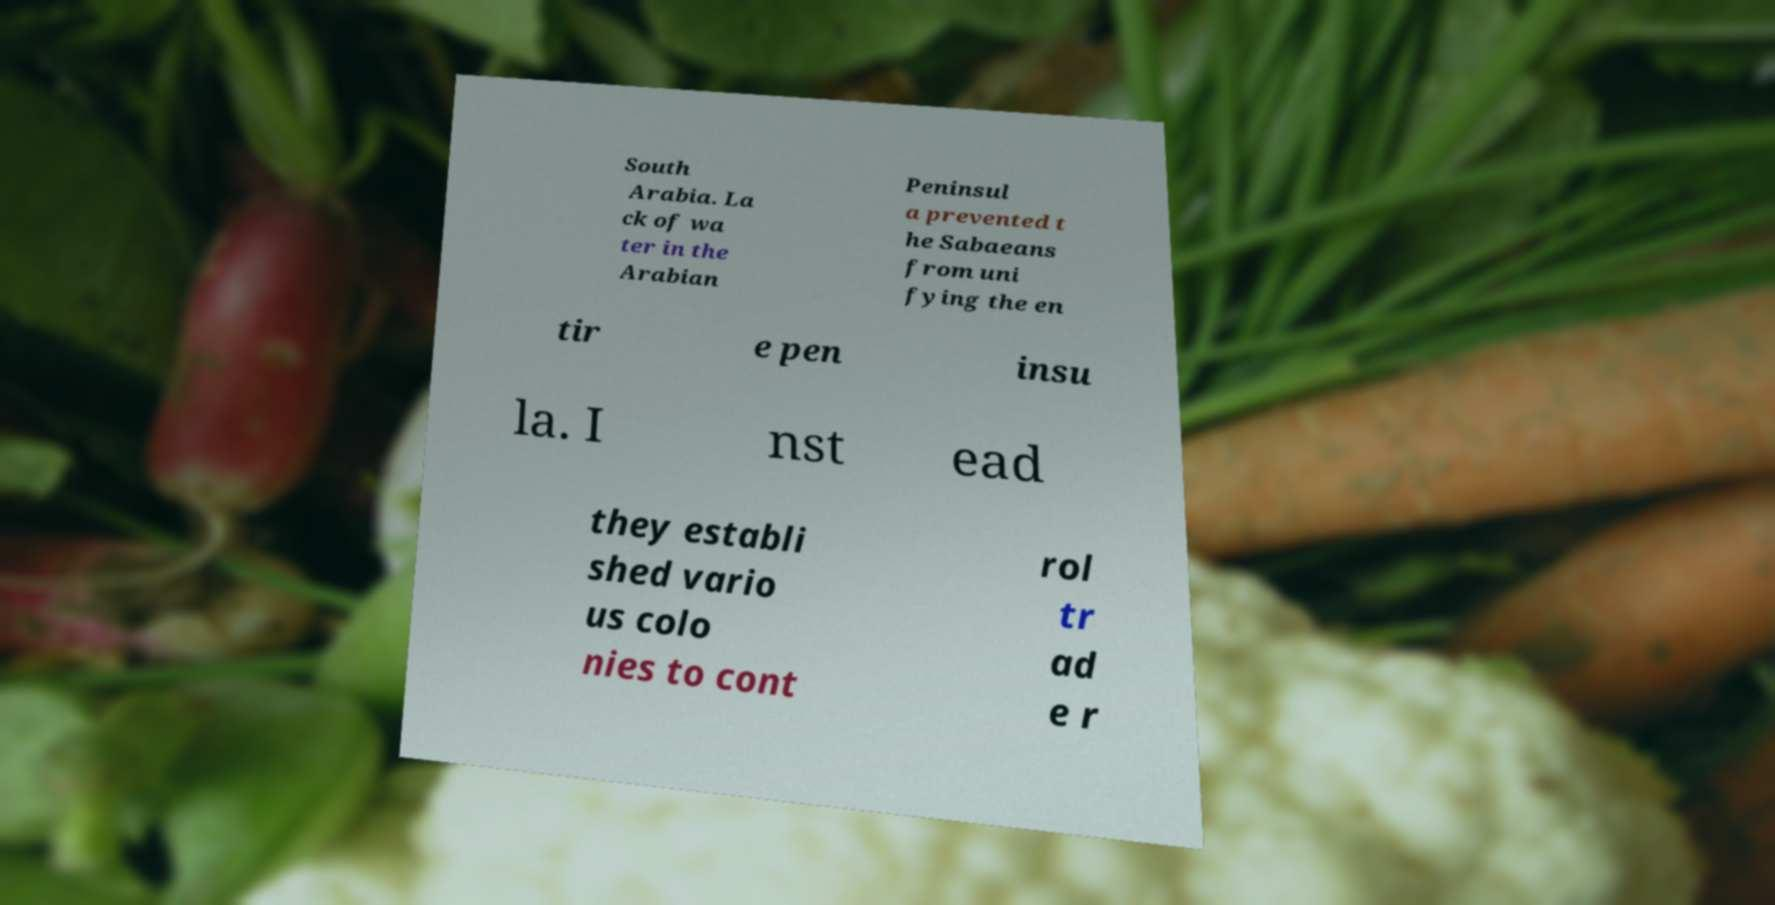Please identify and transcribe the text found in this image. South Arabia. La ck of wa ter in the Arabian Peninsul a prevented t he Sabaeans from uni fying the en tir e pen insu la. I nst ead they establi shed vario us colo nies to cont rol tr ad e r 